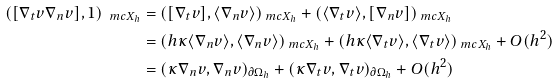Convert formula to latex. <formula><loc_0><loc_0><loc_500><loc_500>( [ \nabla _ { t } v \nabla _ { n } v ] , 1 ) _ { \ m c X _ { h } } & = ( [ \nabla _ { t } v ] , \langle \nabla _ { n } v \rangle ) _ { \ m c X _ { h } } + ( \langle \nabla _ { t } v \rangle , [ \nabla _ { n } v ] ) _ { \ m c X _ { h } } \\ & = ( h \kappa \langle \nabla _ { n } v \rangle , \langle \nabla _ { n } v \rangle ) _ { \ m c X _ { h } } + ( h \kappa \langle \nabla _ { t } v \rangle , \langle \nabla _ { t } v \rangle ) _ { \ m c X _ { h } } + O ( h ^ { 2 } ) \\ & = ( \kappa \nabla _ { n } v , \nabla _ { n } v ) _ { \partial \Omega _ { h } } + ( \kappa \nabla _ { t } v , \nabla _ { t } v ) _ { \partial \Omega _ { h } } + O ( h ^ { 2 } )</formula> 